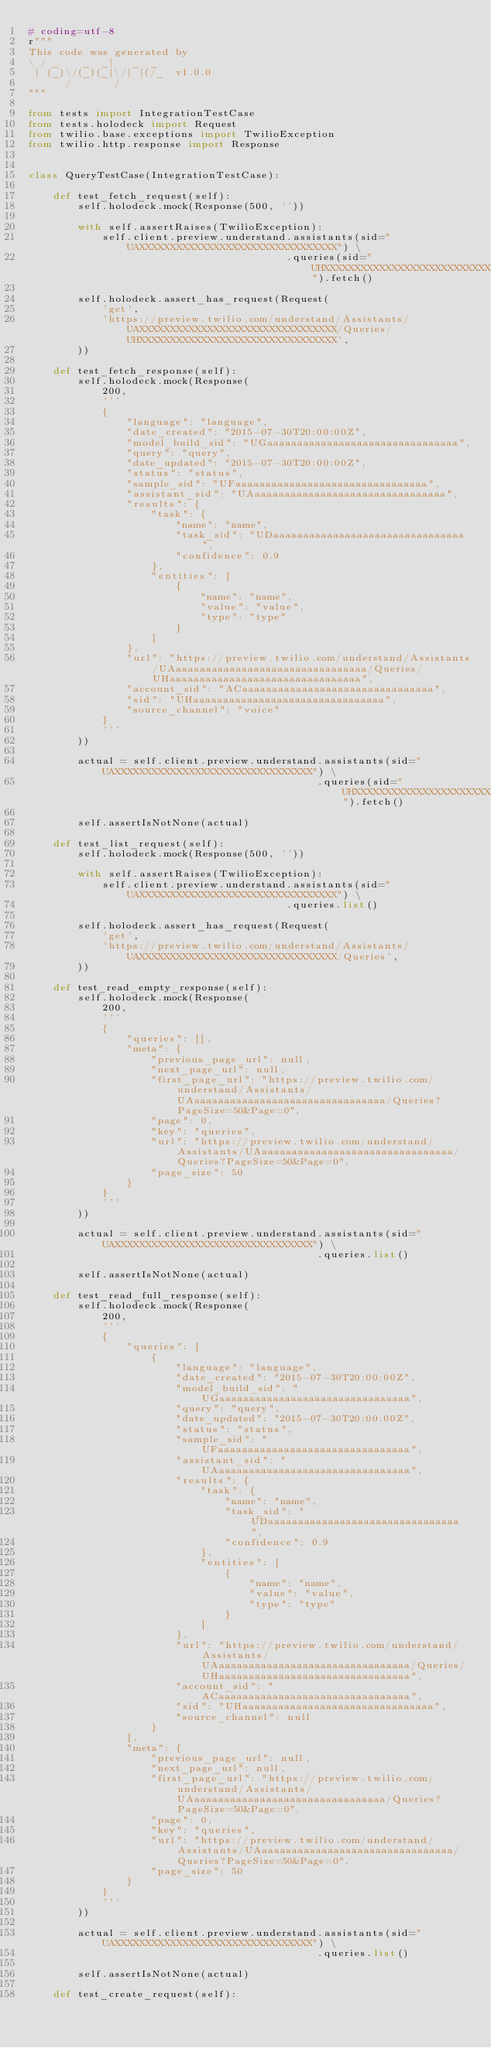<code> <loc_0><loc_0><loc_500><loc_500><_Python_># coding=utf-8
r"""
This code was generated by
\ / _    _  _|   _  _
 | (_)\/(_)(_|\/| |(/_  v1.0.0
      /       /
"""

from tests import IntegrationTestCase
from tests.holodeck import Request
from twilio.base.exceptions import TwilioException
from twilio.http.response import Response


class QueryTestCase(IntegrationTestCase):

    def test_fetch_request(self):
        self.holodeck.mock(Response(500, ''))

        with self.assertRaises(TwilioException):
            self.client.preview.understand.assistants(sid="UAXXXXXXXXXXXXXXXXXXXXXXXXXXXXXXXX") \
                                          .queries(sid="UHXXXXXXXXXXXXXXXXXXXXXXXXXXXXXXXX").fetch()

        self.holodeck.assert_has_request(Request(
            'get',
            'https://preview.twilio.com/understand/Assistants/UAXXXXXXXXXXXXXXXXXXXXXXXXXXXXXXXX/Queries/UHXXXXXXXXXXXXXXXXXXXXXXXXXXXXXXXX',
        ))

    def test_fetch_response(self):
        self.holodeck.mock(Response(
            200,
            '''
            {
                "language": "language",
                "date_created": "2015-07-30T20:00:00Z",
                "model_build_sid": "UGaaaaaaaaaaaaaaaaaaaaaaaaaaaaaaaa",
                "query": "query",
                "date_updated": "2015-07-30T20:00:00Z",
                "status": "status",
                "sample_sid": "UFaaaaaaaaaaaaaaaaaaaaaaaaaaaaaaaa",
                "assistant_sid": "UAaaaaaaaaaaaaaaaaaaaaaaaaaaaaaaaa",
                "results": {
                    "task": {
                        "name": "name",
                        "task_sid": "UDaaaaaaaaaaaaaaaaaaaaaaaaaaaaaaaa",
                        "confidence": 0.9
                    },
                    "entities": [
                        {
                            "name": "name",
                            "value": "value",
                            "type": "type"
                        }
                    ]
                },
                "url": "https://preview.twilio.com/understand/Assistants/UAaaaaaaaaaaaaaaaaaaaaaaaaaaaaaaaa/Queries/UHaaaaaaaaaaaaaaaaaaaaaaaaaaaaaaaa",
                "account_sid": "ACaaaaaaaaaaaaaaaaaaaaaaaaaaaaaaaa",
                "sid": "UHaaaaaaaaaaaaaaaaaaaaaaaaaaaaaaaa",
                "source_channel": "voice"
            }
            '''
        ))

        actual = self.client.preview.understand.assistants(sid="UAXXXXXXXXXXXXXXXXXXXXXXXXXXXXXXXX") \
                                               .queries(sid="UHXXXXXXXXXXXXXXXXXXXXXXXXXXXXXXXX").fetch()

        self.assertIsNotNone(actual)

    def test_list_request(self):
        self.holodeck.mock(Response(500, ''))

        with self.assertRaises(TwilioException):
            self.client.preview.understand.assistants(sid="UAXXXXXXXXXXXXXXXXXXXXXXXXXXXXXXXX") \
                                          .queries.list()

        self.holodeck.assert_has_request(Request(
            'get',
            'https://preview.twilio.com/understand/Assistants/UAXXXXXXXXXXXXXXXXXXXXXXXXXXXXXXXX/Queries',
        ))

    def test_read_empty_response(self):
        self.holodeck.mock(Response(
            200,
            '''
            {
                "queries": [],
                "meta": {
                    "previous_page_url": null,
                    "next_page_url": null,
                    "first_page_url": "https://preview.twilio.com/understand/Assistants/UAaaaaaaaaaaaaaaaaaaaaaaaaaaaaaaaa/Queries?PageSize=50&Page=0",
                    "page": 0,
                    "key": "queries",
                    "url": "https://preview.twilio.com/understand/Assistants/UAaaaaaaaaaaaaaaaaaaaaaaaaaaaaaaaa/Queries?PageSize=50&Page=0",
                    "page_size": 50
                }
            }
            '''
        ))

        actual = self.client.preview.understand.assistants(sid="UAXXXXXXXXXXXXXXXXXXXXXXXXXXXXXXXX") \
                                               .queries.list()

        self.assertIsNotNone(actual)

    def test_read_full_response(self):
        self.holodeck.mock(Response(
            200,
            '''
            {
                "queries": [
                    {
                        "language": "language",
                        "date_created": "2015-07-30T20:00:00Z",
                        "model_build_sid": "UGaaaaaaaaaaaaaaaaaaaaaaaaaaaaaaaa",
                        "query": "query",
                        "date_updated": "2015-07-30T20:00:00Z",
                        "status": "status",
                        "sample_sid": "UFaaaaaaaaaaaaaaaaaaaaaaaaaaaaaaaa",
                        "assistant_sid": "UAaaaaaaaaaaaaaaaaaaaaaaaaaaaaaaaa",
                        "results": {
                            "task": {
                                "name": "name",
                                "task_sid": "UDaaaaaaaaaaaaaaaaaaaaaaaaaaaaaaaa",
                                "confidence": 0.9
                            },
                            "entities": [
                                {
                                    "name": "name",
                                    "value": "value",
                                    "type": "type"
                                }
                            ]
                        },
                        "url": "https://preview.twilio.com/understand/Assistants/UAaaaaaaaaaaaaaaaaaaaaaaaaaaaaaaaa/Queries/UHaaaaaaaaaaaaaaaaaaaaaaaaaaaaaaaa",
                        "account_sid": "ACaaaaaaaaaaaaaaaaaaaaaaaaaaaaaaaa",
                        "sid": "UHaaaaaaaaaaaaaaaaaaaaaaaaaaaaaaaa",
                        "source_channel": null
                    }
                ],
                "meta": {
                    "previous_page_url": null,
                    "next_page_url": null,
                    "first_page_url": "https://preview.twilio.com/understand/Assistants/UAaaaaaaaaaaaaaaaaaaaaaaaaaaaaaaaa/Queries?PageSize=50&Page=0",
                    "page": 0,
                    "key": "queries",
                    "url": "https://preview.twilio.com/understand/Assistants/UAaaaaaaaaaaaaaaaaaaaaaaaaaaaaaaaa/Queries?PageSize=50&Page=0",
                    "page_size": 50
                }
            }
            '''
        ))

        actual = self.client.preview.understand.assistants(sid="UAXXXXXXXXXXXXXXXXXXXXXXXXXXXXXXXX") \
                                               .queries.list()

        self.assertIsNotNone(actual)

    def test_create_request(self):</code> 